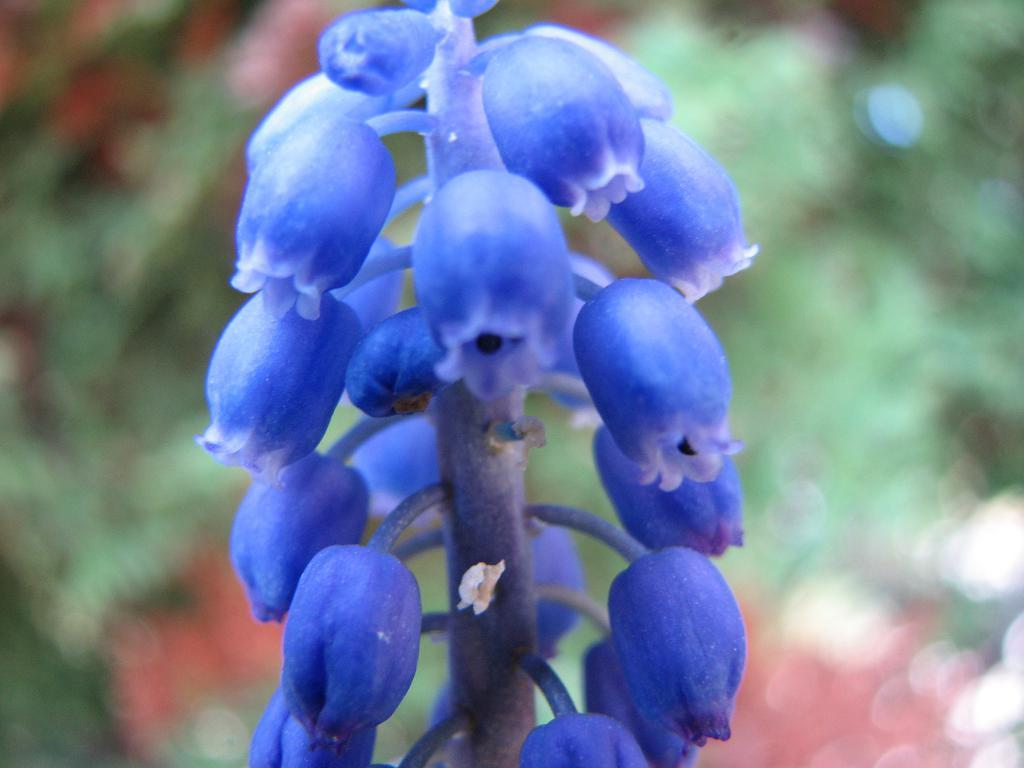What is the main subject of the image? The main subject of the image is a stem. What is attached to the stem? There are flowers attached to the stem. What can be seen in the background of the image? There is greenery in the background of the image. What type of doctor can be seen examining the flowers in the image? There is no doctor present in the image, and the flowers are not being examined by anyone. 